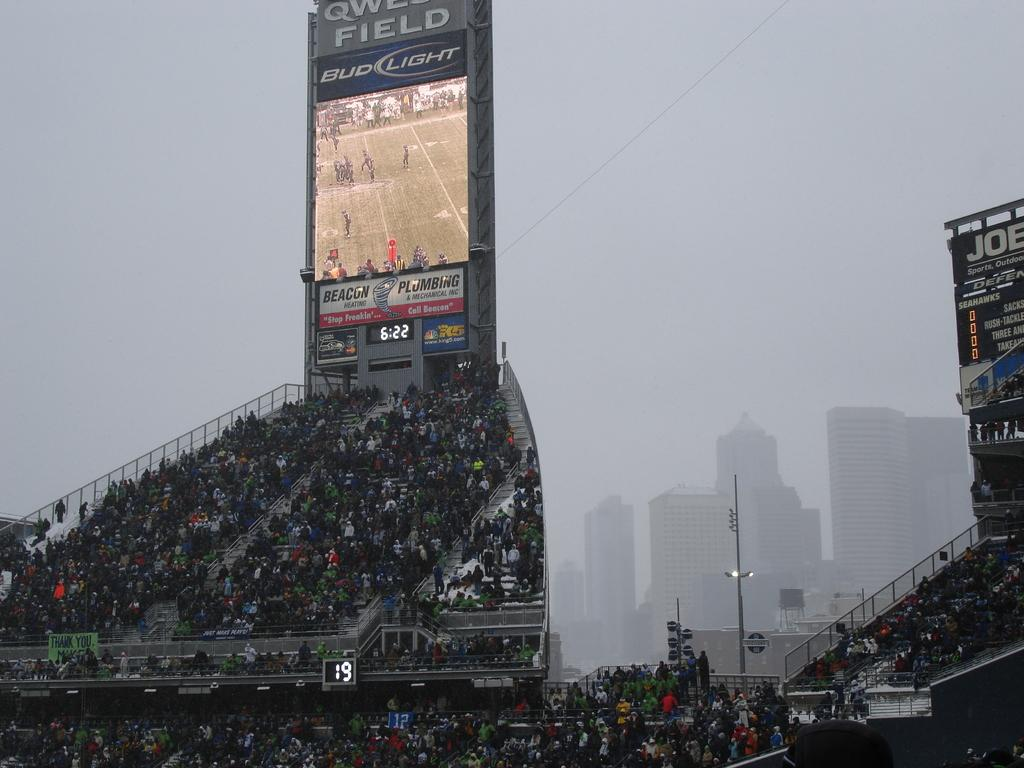<image>
Provide a brief description of the given image. A large stadium television with the sponsor Bud Light prominently featured. 